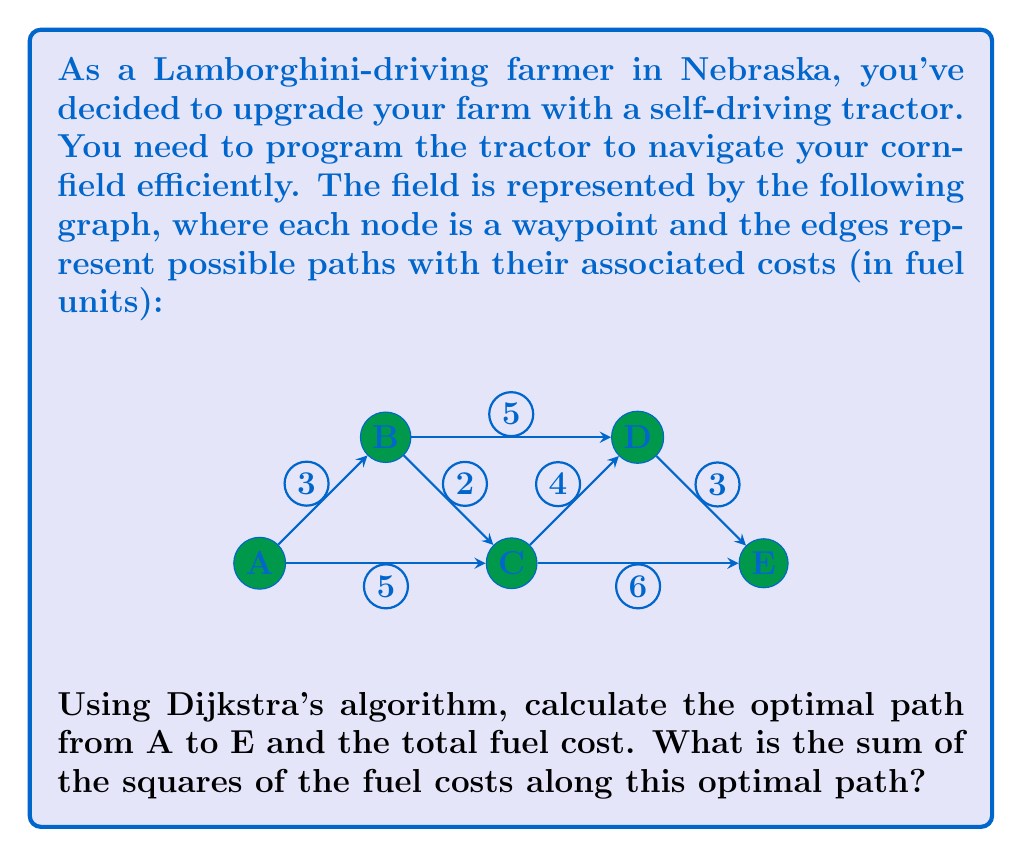Could you help me with this problem? Let's solve this step-by-step using Dijkstra's algorithm:

1) Initialize:
   - Distance to A: 0
   - Distance to all other nodes: ∞

2) Visit A:
   - Update B: min(∞, 0+3) = 3
   - Update C: min(∞, 0+5) = 5

3) Visit B (closest unvisited node):
   - Update C: min(5, 3+2) = 5 (no change)
   - Update D: min(∞, 3+5) = 8

4) Visit C:
   - Update D: min(8, 5+4) = 8 (no change)
   - Update E: min(∞, 5+6) = 11

5) Visit D:
   - Update E: min(11, 8+3) = 11 (no change)

6) Visit E (destination reached)

The optimal path is A → C → E with a total fuel cost of 11 units.

Now, let's calculate the sum of the squares of the fuel costs along this path:

$$ 5^2 + 6^2 = 25 + 36 = 61 $$
Answer: 61 